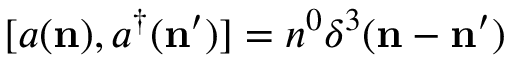Convert formula to latex. <formula><loc_0><loc_0><loc_500><loc_500>[ a ( { n } ) , a ^ { \dagger } ( { n } ^ { \prime } ) ] = n ^ { 0 } \delta ^ { 3 } ( { n } - { n } ^ { \prime } )</formula> 